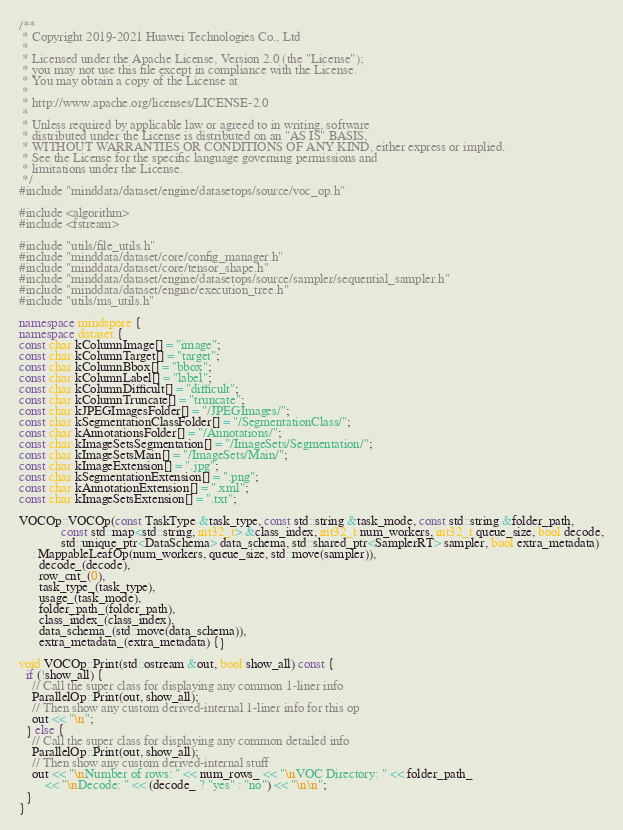<code> <loc_0><loc_0><loc_500><loc_500><_C++_>/**
 * Copyright 2019-2021 Huawei Technologies Co., Ltd
 *
 * Licensed under the Apache License, Version 2.0 (the "License");
 * you may not use this file except in compliance with the License.
 * You may obtain a copy of the License at
 *
 * http://www.apache.org/licenses/LICENSE-2.0
 *
 * Unless required by applicable law or agreed to in writing, software
 * distributed under the License is distributed on an "AS IS" BASIS,
 * WITHOUT WARRANTIES OR CONDITIONS OF ANY KIND, either express or implied.
 * See the License for the specific language governing permissions and
 * limitations under the License.
 */
#include "minddata/dataset/engine/datasetops/source/voc_op.h"

#include <algorithm>
#include <fstream>

#include "utils/file_utils.h"
#include "minddata/dataset/core/config_manager.h"
#include "minddata/dataset/core/tensor_shape.h"
#include "minddata/dataset/engine/datasetops/source/sampler/sequential_sampler.h"
#include "minddata/dataset/engine/execution_tree.h"
#include "utils/ms_utils.h"

namespace mindspore {
namespace dataset {
const char kColumnImage[] = "image";
const char kColumnTarget[] = "target";
const char kColumnBbox[] = "bbox";
const char kColumnLabel[] = "label";
const char kColumnDifficult[] = "difficult";
const char kColumnTruncate[] = "truncate";
const char kJPEGImagesFolder[] = "/JPEGImages/";
const char kSegmentationClassFolder[] = "/SegmentationClass/";
const char kAnnotationsFolder[] = "/Annotations/";
const char kImageSetsSegmentation[] = "/ImageSets/Segmentation/";
const char kImageSetsMain[] = "/ImageSets/Main/";
const char kImageExtension[] = ".jpg";
const char kSegmentationExtension[] = ".png";
const char kAnnotationExtension[] = ".xml";
const char kImageSetsExtension[] = ".txt";

VOCOp::VOCOp(const TaskType &task_type, const std::string &task_mode, const std::string &folder_path,
             const std::map<std::string, int32_t> &class_index, int32_t num_workers, int32_t queue_size, bool decode,
             std::unique_ptr<DataSchema> data_schema, std::shared_ptr<SamplerRT> sampler, bool extra_metadata)
    : MappableLeafOp(num_workers, queue_size, std::move(sampler)),
      decode_(decode),
      row_cnt_(0),
      task_type_(task_type),
      usage_(task_mode),
      folder_path_(folder_path),
      class_index_(class_index),
      data_schema_(std::move(data_schema)),
      extra_metadata_(extra_metadata) {}

void VOCOp::Print(std::ostream &out, bool show_all) const {
  if (!show_all) {
    // Call the super class for displaying any common 1-liner info
    ParallelOp::Print(out, show_all);
    // Then show any custom derived-internal 1-liner info for this op
    out << "\n";
  } else {
    // Call the super class for displaying any common detailed info
    ParallelOp::Print(out, show_all);
    // Then show any custom derived-internal stuff
    out << "\nNumber of rows: " << num_rows_ << "\nVOC Directory: " << folder_path_
        << "\nDecode: " << (decode_ ? "yes" : "no") << "\n\n";
  }
}
</code> 